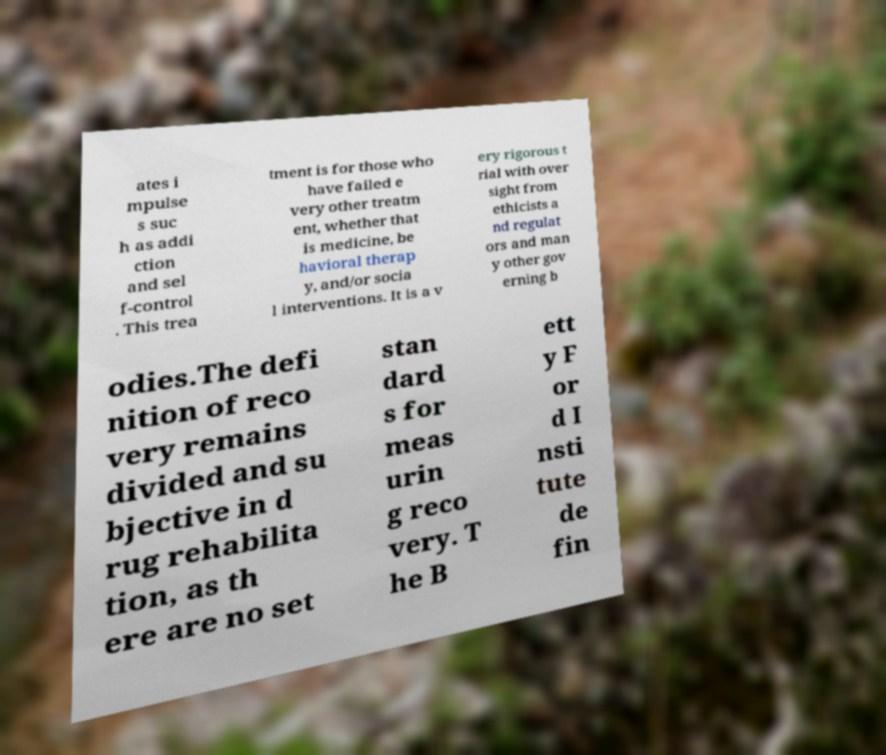Please read and relay the text visible in this image. What does it say? ates i mpulse s suc h as addi ction and sel f-control . This trea tment is for those who have failed e very other treatm ent, whether that is medicine, be havioral therap y, and/or socia l interventions. It is a v ery rigorous t rial with over sight from ethicists a nd regulat ors and man y other gov erning b odies.The defi nition of reco very remains divided and su bjective in d rug rehabilita tion, as th ere are no set stan dard s for meas urin g reco very. T he B ett y F or d I nsti tute de fin 